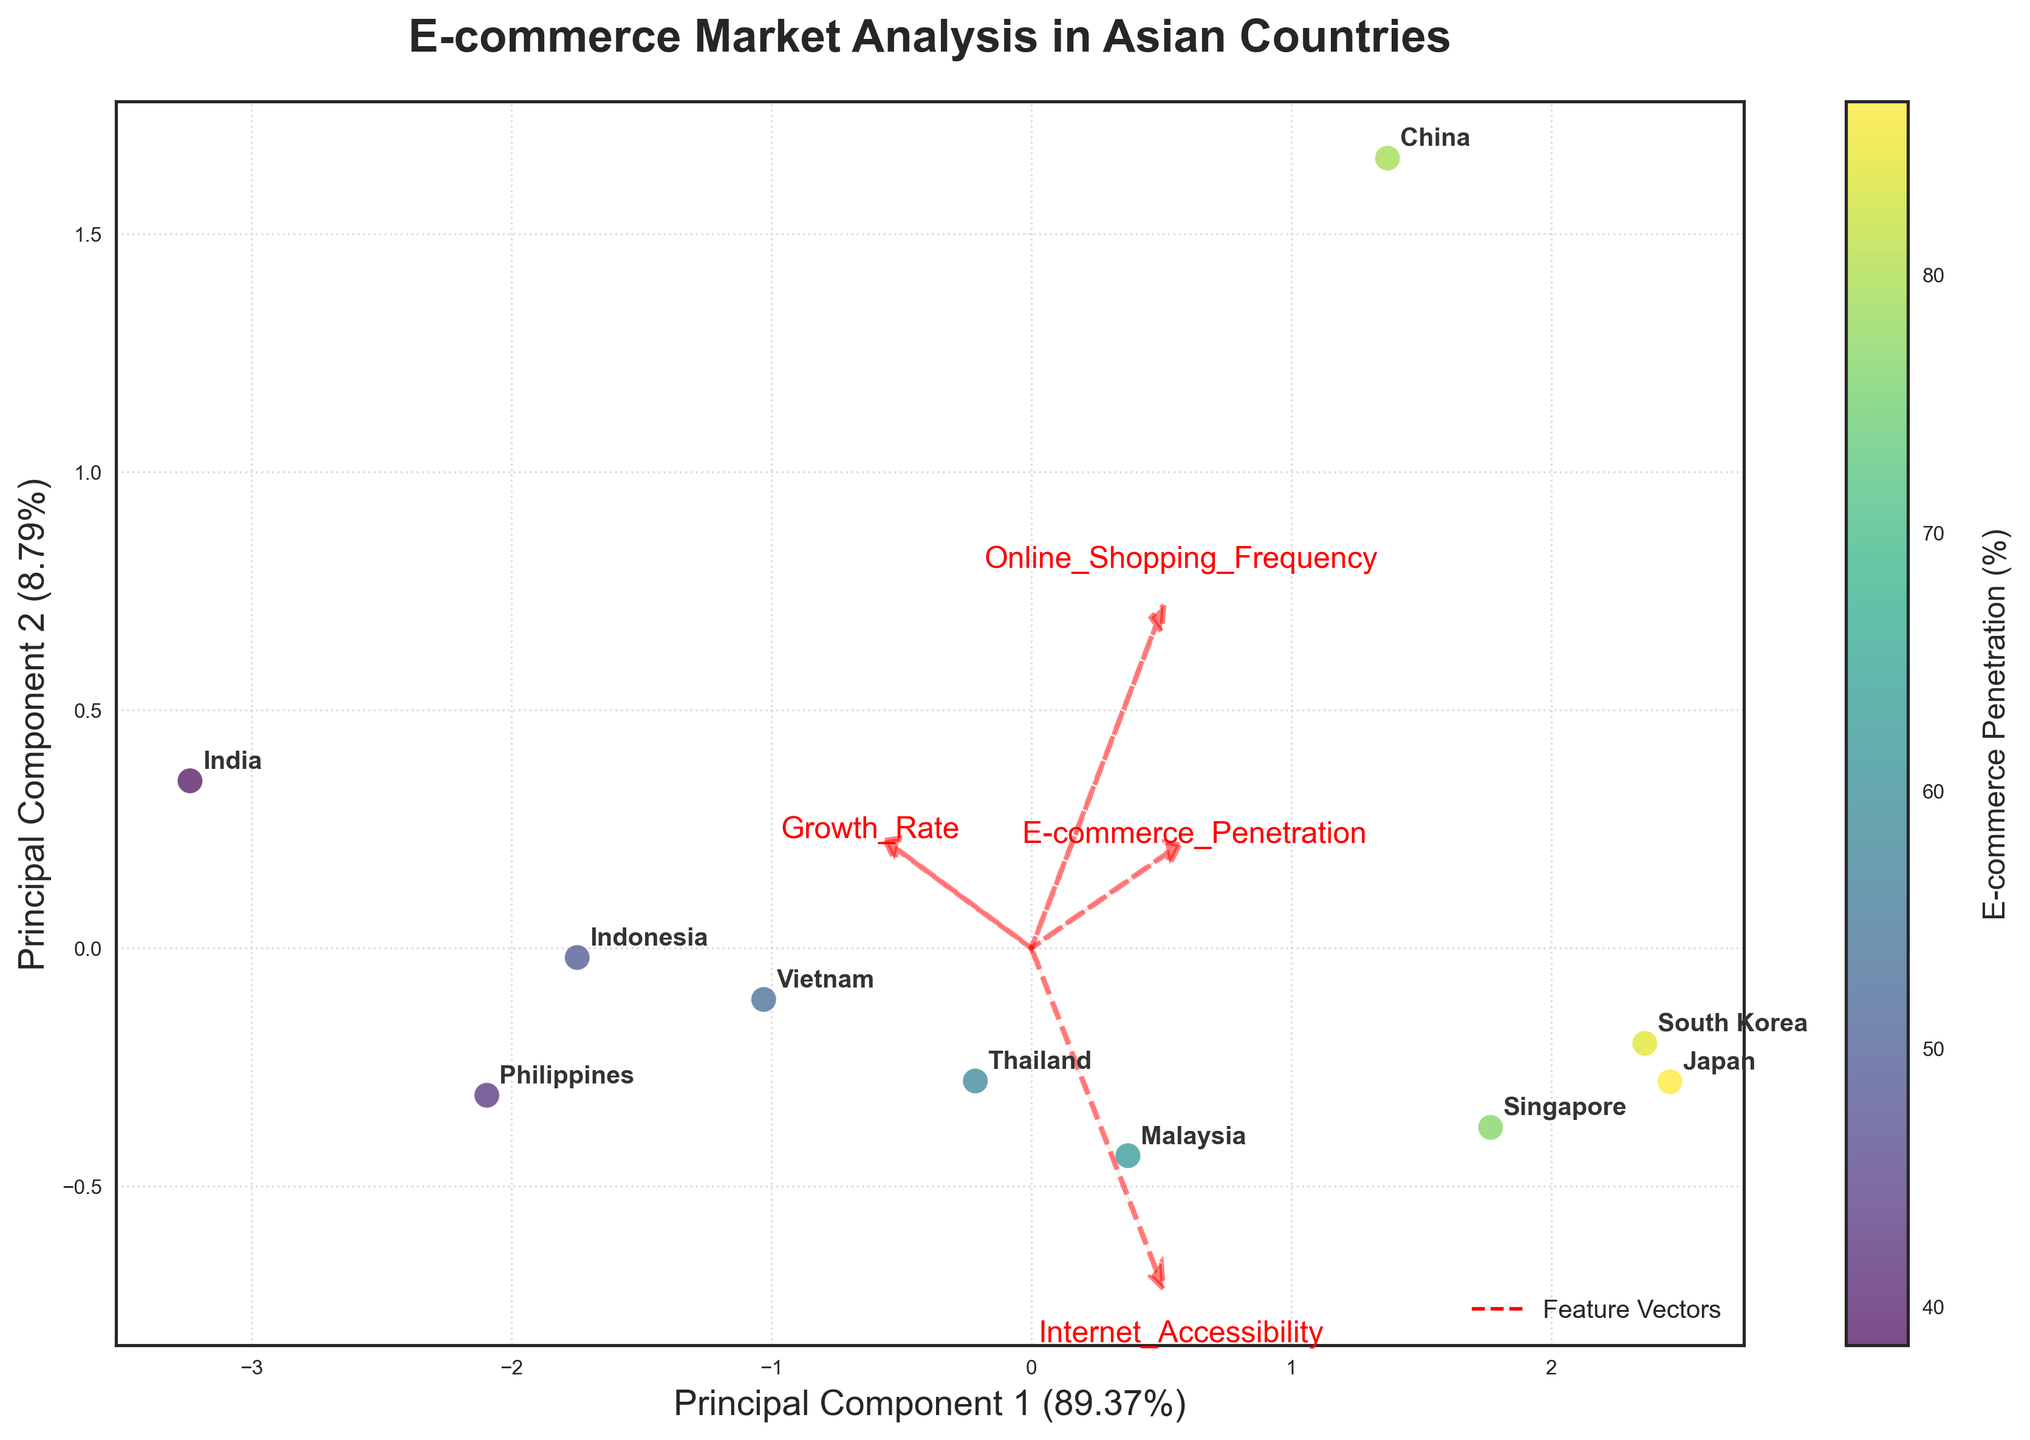what is the title of the figure? The title is located at the top of the figure and is styled in bold.
Answer: E-commerce Market Analysis in Asian Countries What are the x and y axes labeled? The labels on the axes explain what principal components are being plotted and their variance. The x-axis shows Principal Component 1 while the y-axis shows Principal Component 2.
Answer: Principal Component 1 and Principal Component 2 Which country has the highest E-commerce penetration rate based on the color of the scatter points? The scatter points are colored according to the E-commerce penetration rate, as indicated by the color bar on the right side of the plot. Japan is the most prominent green color, indicating the highest penetration rate.
Answer: Japan What features are indicated by the red arrows? The plot contains red arrows originating from the origin, and their respective texts identify four features: E-commerce Penetration, Growth Rate, Internet Accessibility, and Online Shopping Frequency.
Answer: E-commerce Penetration, Growth Rate, Internet Accessibility, and Online Shopping Frequency Which country's data point is closest to the origin, and what implication might this have? By inspecting the scatter points, Singapore is closest to the origin. The closeness to the origin could imply that Singapore's values for the principal components are average compared to other countries.
Answer: Singapore Which countries have shown high growth rates despite lower internet accessibility? To answer this, locate countries with high Growth Rate (denoted by their placement relative to the 'Growth Rate' vector) and check their corresponding Internet Accessibility values (either through the position relative to the 'Internet Accessibility' vector or known data). Vietnam, Indonesia, the Philippines, and India seem to fit this criterion.
Answer: Vietnam, Indonesia, the Philippines, and India How do the positions of China and South Korea compare with respect to the principal components? Evaluate their positions relative to each axis: both China and South Korea are plotted in the positive quadrant of PC1, suggesting similar directions for E-commerce Penetration and Internet Accessibility, but China appears higher on PC2, indicating stronger driving factors in Growth Rate or Online Shopping Frequency.
Answer: China has a higher growth rate or shopping frequency compared to South Korea Which feature appears to have the least correlation with E-commerce Penetration? The arrow vectors provide this insight, where the smallest angle between 'E-commerce Penetration' and other features suggests low correlation: Online Shopping Frequency and Growth Rate vectors are noticeably distant or almost orthogonal, indicating less correlation.
Answer: Online Shopping Frequency What does the explained variance ratio suggest about the PCA model? Look at the variance percentages shown in the labels of the x and y axes: Principal Component 1 explains a slightly higher percentage of the variance compared to Principal Component 2, suggesting both components retain substantial but not total variance.
Answer: Principal Components together explain less than 100% variance Which countries can be considered as having balanced but moderate E-commerce settings? Assessing scatter points that cluster near the middle of both principal components, indicating modest but not extreme data across all factors: Singapore and Malaysia have positions suggest this balanced scenario.
Answer: Singapore and Malaysia 